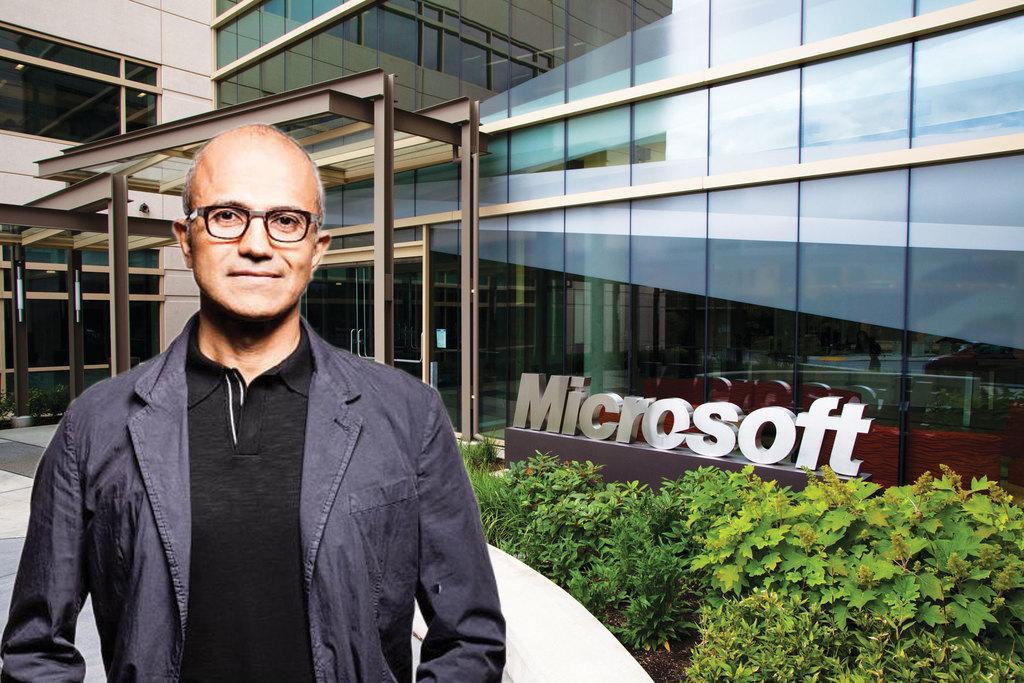Please provide a concise description of this image. This image consists of a person wearing a black T-shirt and a jacket. On the right, we can see planets and a building along with the name. At the bottom, there is a path. 